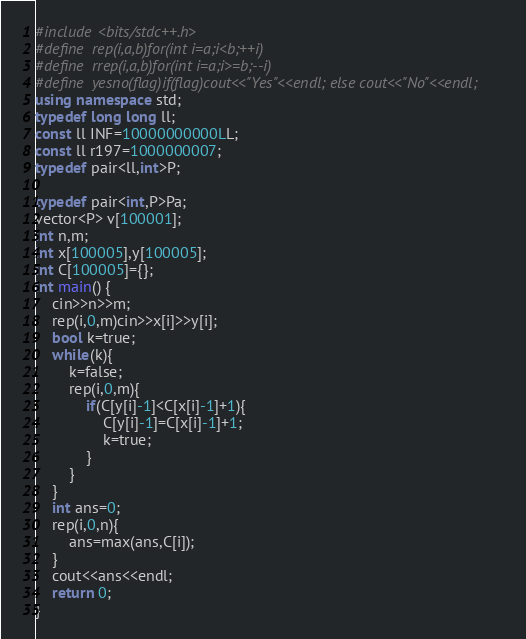<code> <loc_0><loc_0><loc_500><loc_500><_C++_>#include <bits/stdc++.h>
#define  rep(i,a,b)for(int i=a;i<b;++i)
#define  rrep(i,a,b)for(int i=a;i>=b;--i)
#define  yesno(flag)if(flag)cout<<"Yes"<<endl; else cout<<"No"<<endl;
using namespace std;
typedef long long ll;
const ll INF=10000000000LL;
const ll r197=1000000007;
typedef pair<ll,int>P;

typedef pair<int,P>Pa;
vector<P> v[100001];
int n,m;
int x[100005],y[100005];
int C[100005]={};
int main() {
	cin>>n>>m;
	rep(i,0,m)cin>>x[i]>>y[i];
	bool k=true;
	while(k){
		k=false;
		rep(i,0,m){
			if(C[y[i]-1]<C[x[i]-1]+1){
				C[y[i]-1]=C[x[i]-1]+1;
				k=true;
			}
		}
	}
	int ans=0;
	rep(i,0,n){
		ans=max(ans,C[i]);
	}
	cout<<ans<<endl;
	return 0;
}
</code> 